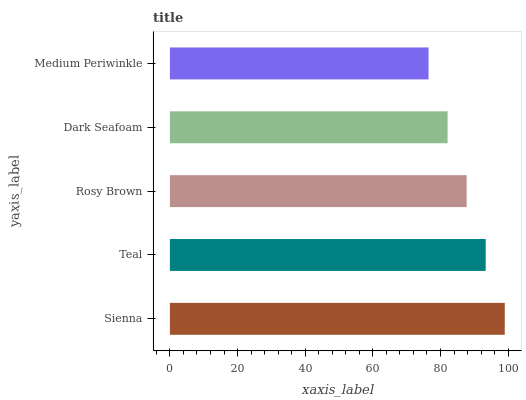Is Medium Periwinkle the minimum?
Answer yes or no. Yes. Is Sienna the maximum?
Answer yes or no. Yes. Is Teal the minimum?
Answer yes or no. No. Is Teal the maximum?
Answer yes or no. No. Is Sienna greater than Teal?
Answer yes or no. Yes. Is Teal less than Sienna?
Answer yes or no. Yes. Is Teal greater than Sienna?
Answer yes or no. No. Is Sienna less than Teal?
Answer yes or no. No. Is Rosy Brown the high median?
Answer yes or no. Yes. Is Rosy Brown the low median?
Answer yes or no. Yes. Is Dark Seafoam the high median?
Answer yes or no. No. Is Medium Periwinkle the low median?
Answer yes or no. No. 